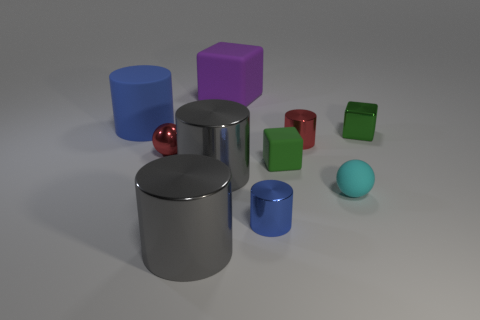Is the green rubber object the same size as the red metal cylinder?
Make the answer very short. Yes. There is a tiny red metal object that is left of the purple matte cube; does it have the same shape as the cyan thing that is to the left of the green shiny object?
Your response must be concise. Yes. What number of large gray objects are there?
Your answer should be very brief. 2. What shape is the tiny green thing that is the same material as the red ball?
Ensure brevity in your answer.  Cube. Is there any other thing that is the same color as the small shiny cube?
Provide a short and direct response. Yes. There is a tiny matte block; is it the same color as the small block behind the metal ball?
Your answer should be compact. Yes. Are there fewer small green rubber blocks that are behind the blue shiny object than cyan spheres?
Keep it short and to the point. No. What material is the ball that is behind the small cyan ball?
Make the answer very short. Metal. How many other objects are the same size as the cyan ball?
Your response must be concise. 5. There is a cyan rubber object; does it have the same size as the sphere that is to the left of the blue shiny object?
Your answer should be compact. Yes. 